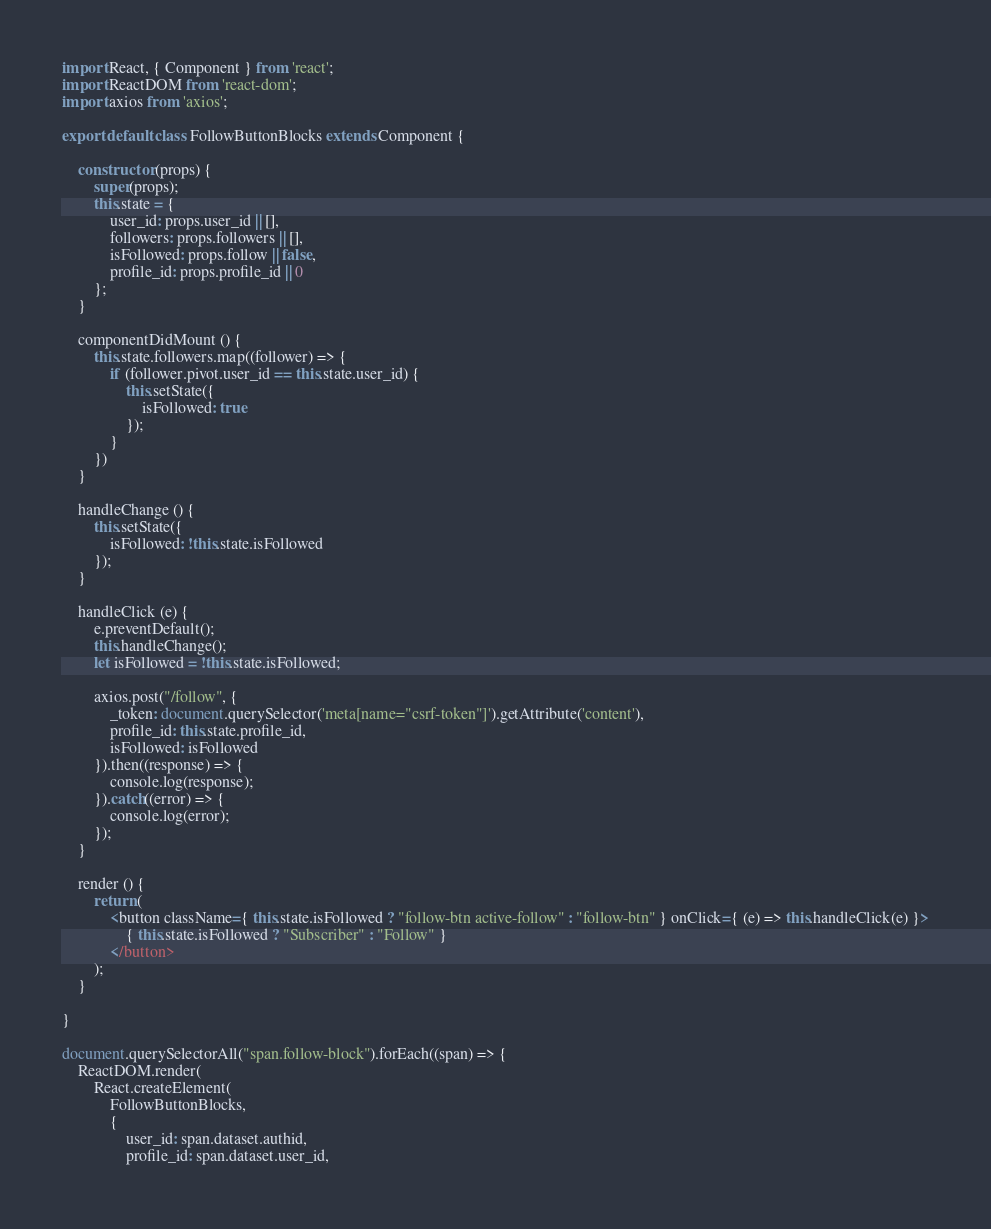Convert code to text. <code><loc_0><loc_0><loc_500><loc_500><_JavaScript_>import React, { Component } from 'react';
import ReactDOM from 'react-dom';
import axios from 'axios';

export default class FollowButtonBlocks extends Component {

    constructor (props) {
        super(props);
        this.state = {
            user_id: props.user_id || [],
            followers: props.followers || [],
            isFollowed: props.follow || false,
            profile_id: props.profile_id || 0
        };
    }

    componentDidMount () {
        this.state.followers.map((follower) => {
            if (follower.pivot.user_id == this.state.user_id) {
                this.setState({
                    isFollowed: true
                });
            }
        })
    }

    handleChange () {
        this.setState({
            isFollowed: !this.state.isFollowed
        });
    }

    handleClick (e) {
        e.preventDefault();
        this.handleChange();
        let isFollowed = !this.state.isFollowed;

        axios.post("/follow", {
            _token: document.querySelector('meta[name="csrf-token"]').getAttribute('content'),
            profile_id: this.state.profile_id,
            isFollowed: isFollowed
        }).then((response) => {
            console.log(response);
        }).catch((error) => {
            console.log(error);
        });
    }

    render () {
        return (
            <button className={ this.state.isFollowed ? "follow-btn active-follow" : "follow-btn" } onClick={ (e) => this.handleClick(e) }>
                { this.state.isFollowed ? "Subscriber" : "Follow" }
            </button>
        );
    }

}

document.querySelectorAll("span.follow-block").forEach((span) => {
    ReactDOM.render(
        React.createElement(
            FollowButtonBlocks,
            {
                user_id: span.dataset.authid,
                profile_id: span.dataset.user_id,</code> 